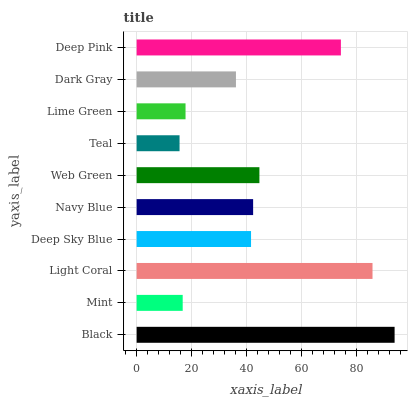Is Teal the minimum?
Answer yes or no. Yes. Is Black the maximum?
Answer yes or no. Yes. Is Mint the minimum?
Answer yes or no. No. Is Mint the maximum?
Answer yes or no. No. Is Black greater than Mint?
Answer yes or no. Yes. Is Mint less than Black?
Answer yes or no. Yes. Is Mint greater than Black?
Answer yes or no. No. Is Black less than Mint?
Answer yes or no. No. Is Navy Blue the high median?
Answer yes or no. Yes. Is Deep Sky Blue the low median?
Answer yes or no. Yes. Is Lime Green the high median?
Answer yes or no. No. Is Web Green the low median?
Answer yes or no. No. 